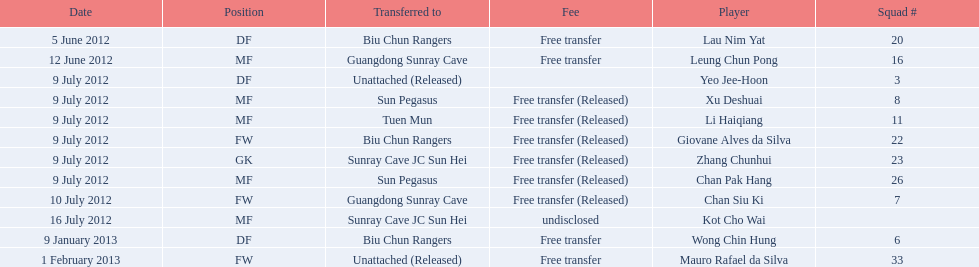I'm looking to parse the entire table for insights. Could you assist me with that? {'header': ['Date', 'Position', 'Transferred to', 'Fee', 'Player', 'Squad #'], 'rows': [['5 June 2012', 'DF', 'Biu Chun Rangers', 'Free transfer', 'Lau Nim Yat', '20'], ['12 June 2012', 'MF', 'Guangdong Sunray Cave', 'Free transfer', 'Leung Chun Pong', '16'], ['9 July 2012', 'DF', 'Unattached (Released)', '', 'Yeo Jee-Hoon', '3'], ['9 July 2012', 'MF', 'Sun Pegasus', 'Free transfer (Released)', 'Xu Deshuai', '8'], ['9 July 2012', 'MF', 'Tuen Mun', 'Free transfer (Released)', 'Li Haiqiang', '11'], ['9 July 2012', 'FW', 'Biu Chun Rangers', 'Free transfer (Released)', 'Giovane Alves da Silva', '22'], ['9 July 2012', 'GK', 'Sunray Cave JC Sun Hei', 'Free transfer (Released)', 'Zhang Chunhui', '23'], ['9 July 2012', 'MF', 'Sun Pegasus', 'Free transfer (Released)', 'Chan Pak Hang', '26'], ['10 July 2012', 'FW', 'Guangdong Sunray Cave', 'Free transfer (Released)', 'Chan Siu Ki', '7'], ['16 July 2012', 'MF', 'Sunray Cave JC Sun Hei', 'undisclosed', 'Kot Cho Wai', ''], ['9 January 2013', 'DF', 'Biu Chun Rangers', 'Free transfer', 'Wong Chin Hung', '6'], ['1 February 2013', 'FW', 'Unattached (Released)', 'Free transfer', 'Mauro Rafael da Silva', '33']]} Lau nim yat and giovane alves de silva where both transferred to which team? Biu Chun Rangers. 